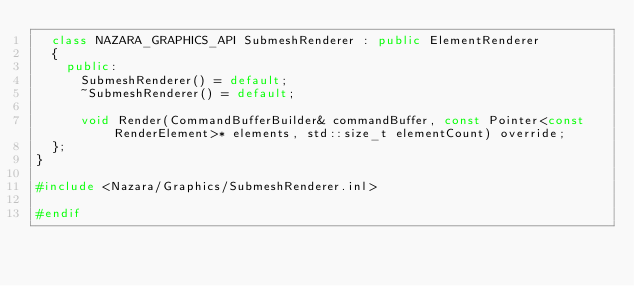<code> <loc_0><loc_0><loc_500><loc_500><_C++_>	class NAZARA_GRAPHICS_API SubmeshRenderer : public ElementRenderer
	{
		public:
			SubmeshRenderer() = default;
			~SubmeshRenderer() = default;

			void Render(CommandBufferBuilder& commandBuffer, const Pointer<const RenderElement>* elements, std::size_t elementCount) override;
	};
}

#include <Nazara/Graphics/SubmeshRenderer.inl>

#endif
</code> 